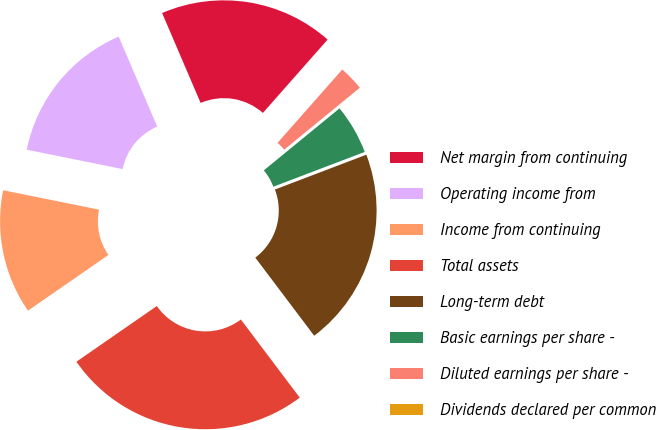<chart> <loc_0><loc_0><loc_500><loc_500><pie_chart><fcel>Net margin from continuing<fcel>Operating income from<fcel>Income from continuing<fcel>Total assets<fcel>Long-term debt<fcel>Basic earnings per share -<fcel>Diluted earnings per share -<fcel>Dividends declared per common<nl><fcel>17.95%<fcel>15.38%<fcel>12.82%<fcel>25.64%<fcel>20.51%<fcel>5.13%<fcel>2.57%<fcel>0.0%<nl></chart> 